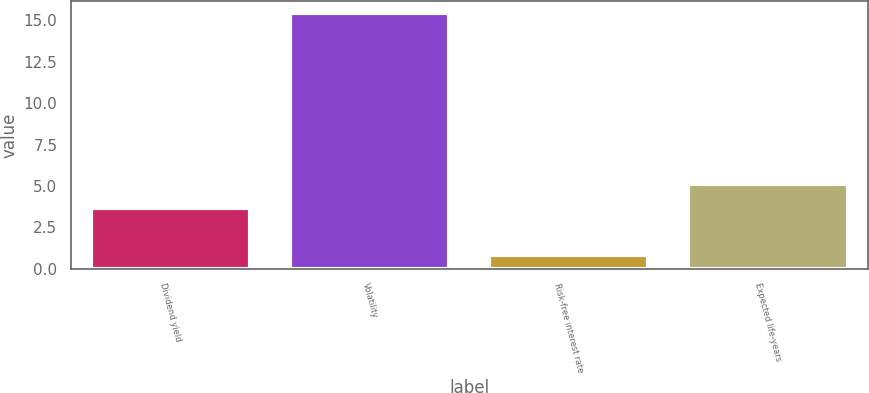Convert chart. <chart><loc_0><loc_0><loc_500><loc_500><bar_chart><fcel>Dividend yield<fcel>Volatility<fcel>Risk-free interest rate<fcel>Expected life-years<nl><fcel>3.7<fcel>15.4<fcel>0.87<fcel>5.15<nl></chart> 